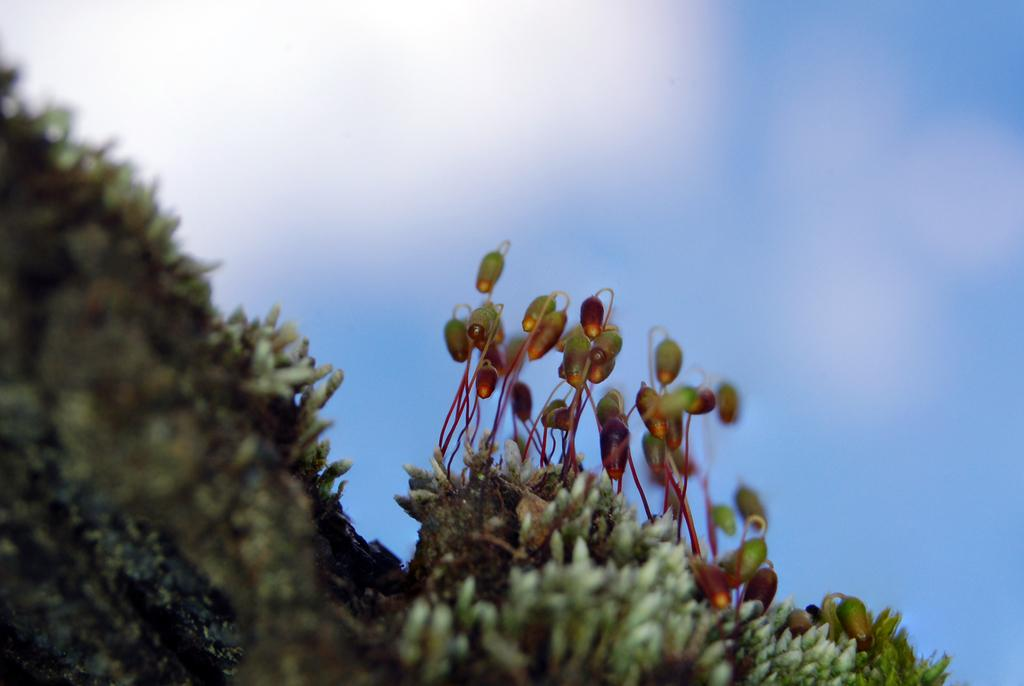What celestial bodies can be seen in the image? There are planets visible in the image. What is the background of the image? The sky is visible in the image. What type of minister is depicted in the image? There is no minister present in the image; it features planets and the sky. What is the result of the crush in the image? There is no crush present in the image; it features planets and the sky. 